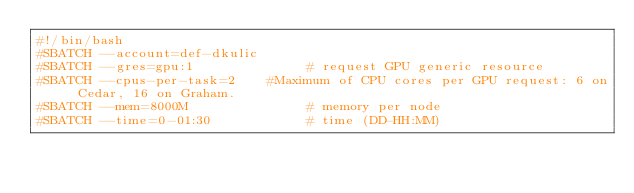<code> <loc_0><loc_0><loc_500><loc_500><_Bash_>#!/bin/bash
#SBATCH --account=def-dkulic
#SBATCH --gres=gpu:1              # request GPU generic resource
#SBATCH --cpus-per-task=2    #Maximum of CPU cores per GPU request: 6 on Cedar, 16 on Graham.
#SBATCH --mem=8000M               # memory per node
#SBATCH --time=0-01:30            # time (DD-HH:MM)</code> 